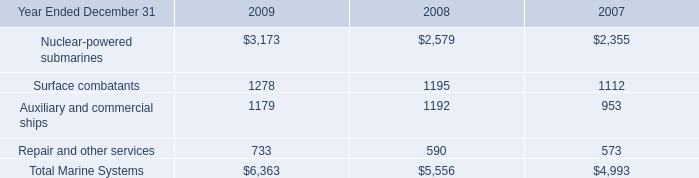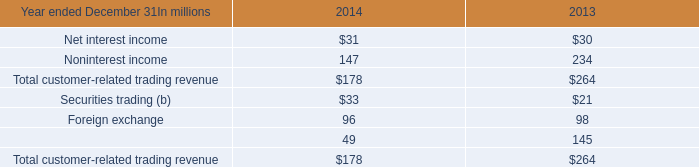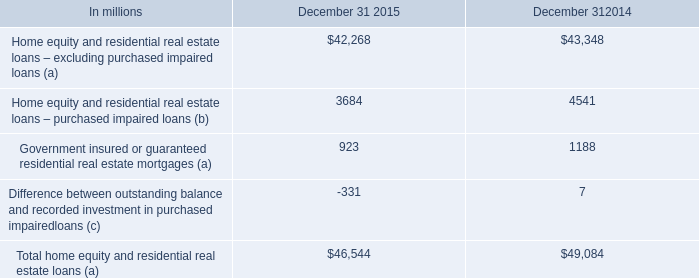What is the difference between 2014 and 2015 's highest element ? 
Computations: (49084 - 46544)
Answer: 2540.0. 